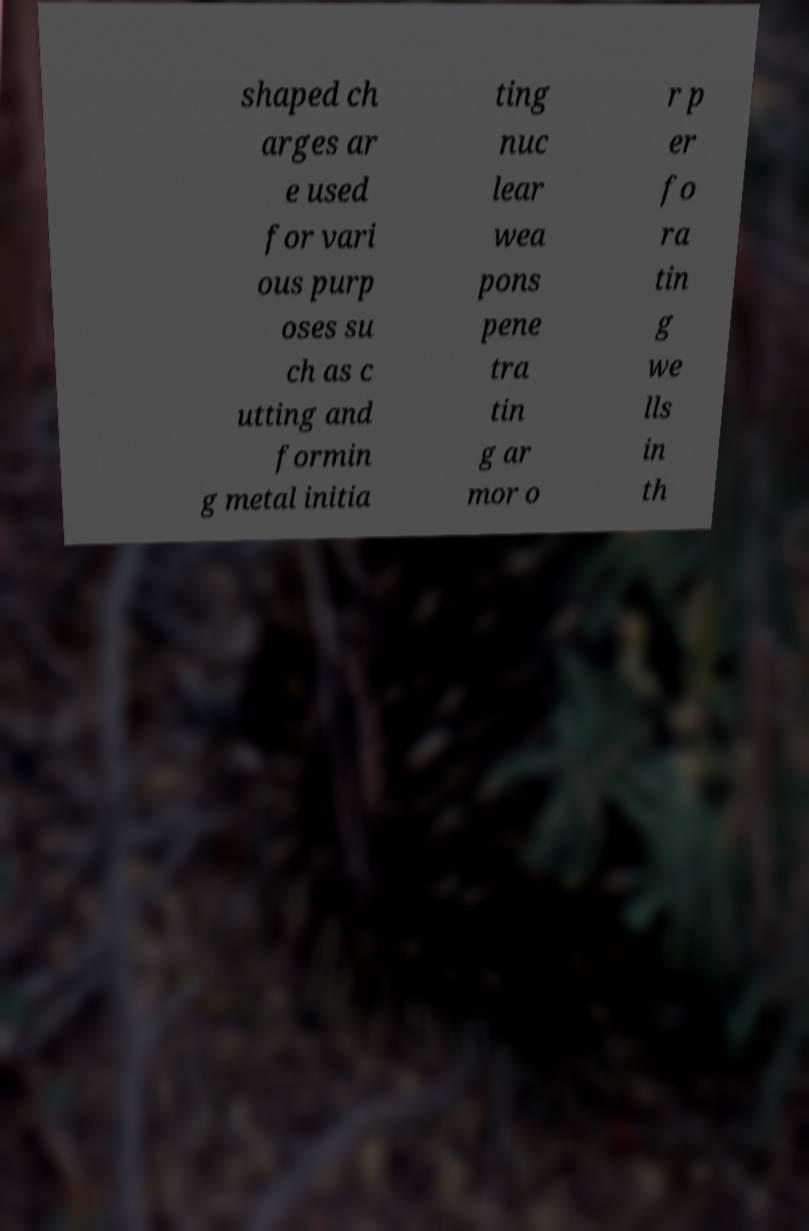Can you read and provide the text displayed in the image?This photo seems to have some interesting text. Can you extract and type it out for me? shaped ch arges ar e used for vari ous purp oses su ch as c utting and formin g metal initia ting nuc lear wea pons pene tra tin g ar mor o r p er fo ra tin g we lls in th 